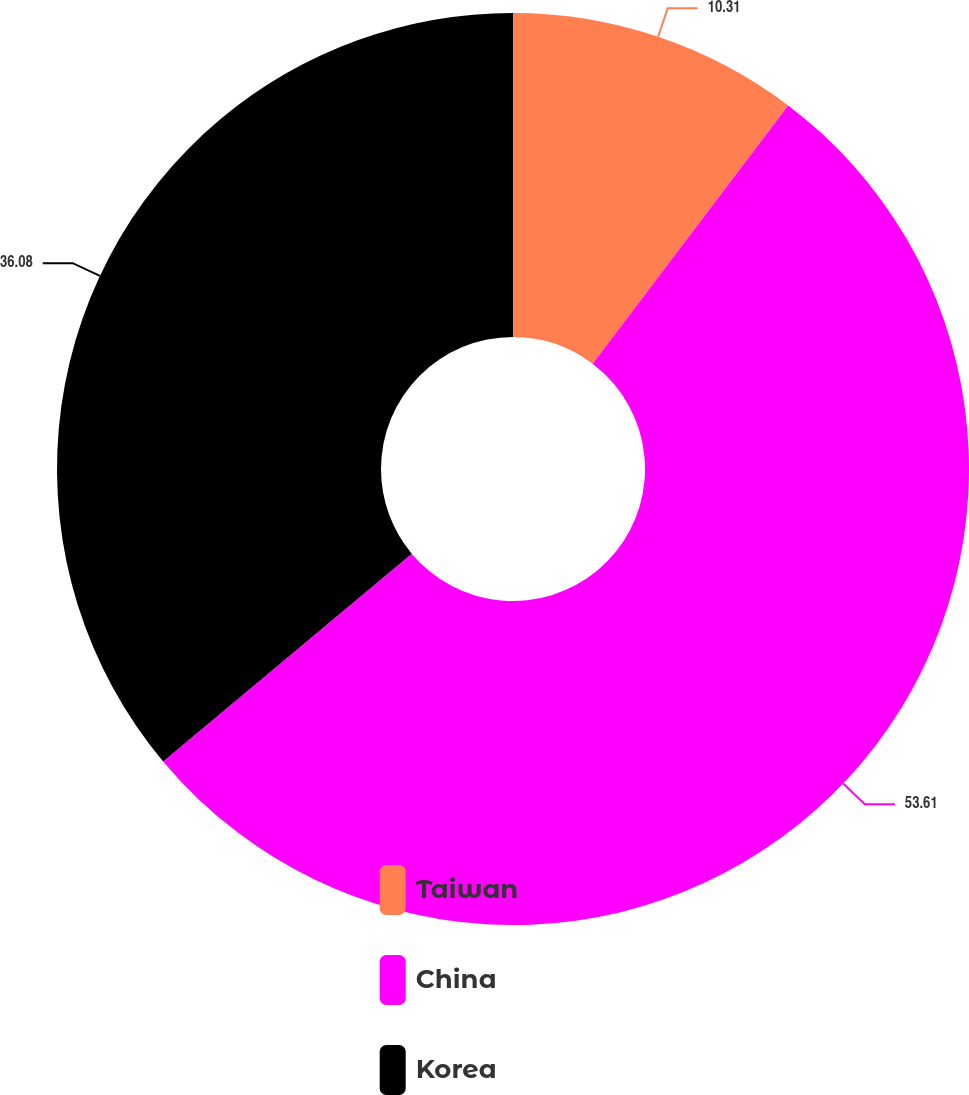Convert chart. <chart><loc_0><loc_0><loc_500><loc_500><pie_chart><fcel>Taiwan<fcel>China<fcel>Korea<nl><fcel>10.31%<fcel>53.61%<fcel>36.08%<nl></chart> 